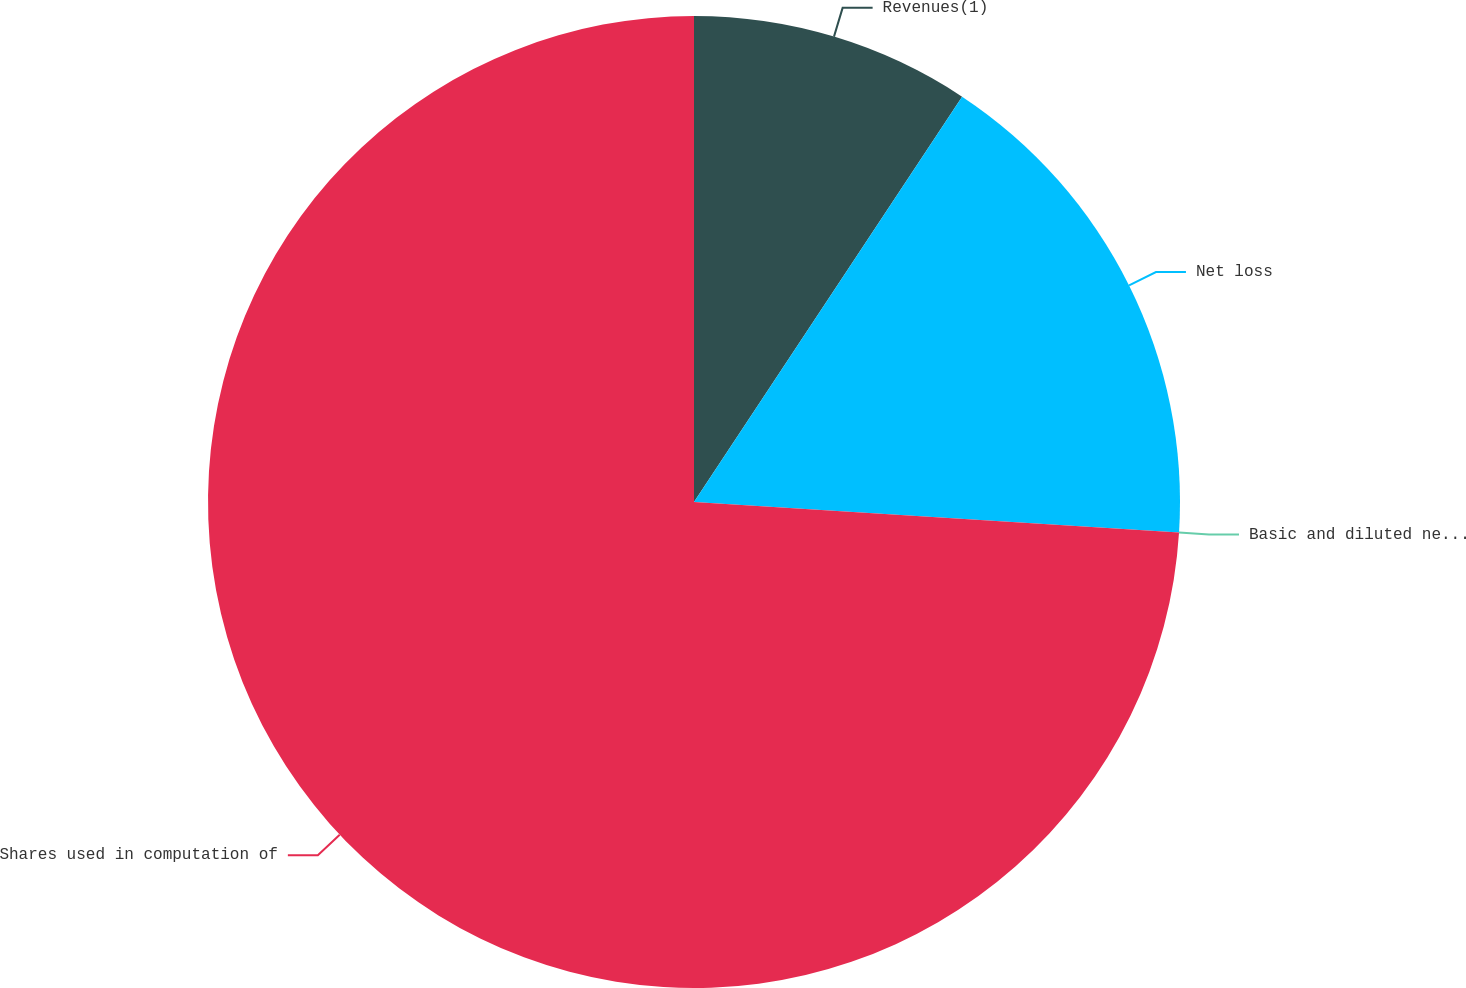<chart> <loc_0><loc_0><loc_500><loc_500><pie_chart><fcel>Revenues(1)<fcel>Net loss<fcel>Basic and diluted net loss per<fcel>Shares used in computation of<nl><fcel>9.3%<fcel>16.7%<fcel>0.0%<fcel>74.0%<nl></chart> 